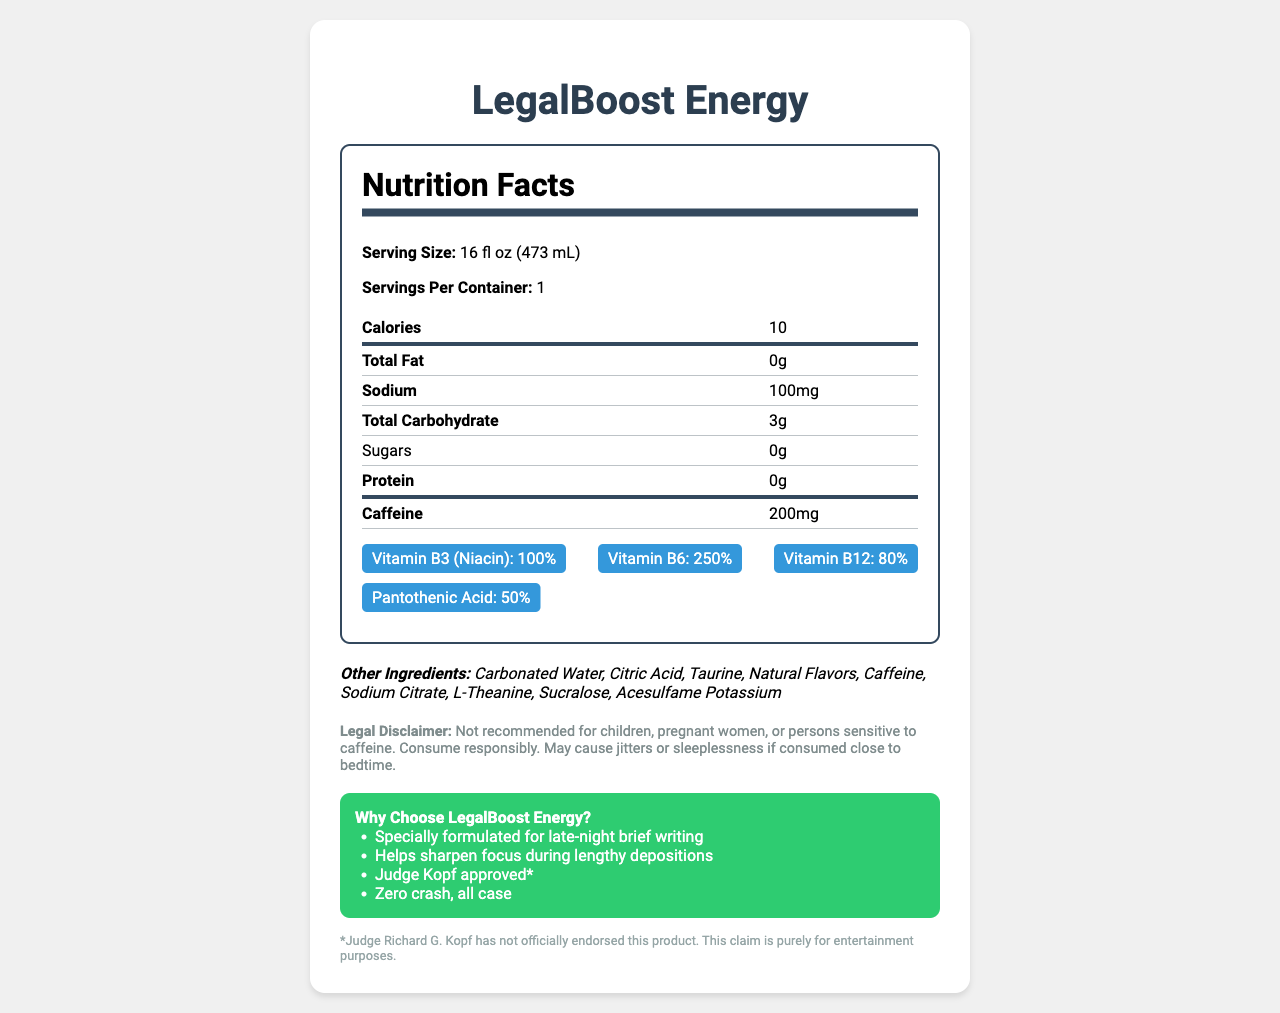What is the serving size of LegalBoost Energy? The document specifies that the serving size of LegalBoost Energy is 16 fl oz (473 mL).
Answer: 16 fl oz (473 mL) How many calories are in one serving of LegalBoost Energy? The document lists the calories per serving as 10.
Answer: 10 How much caffeine is there in one serving of LegalBoost Energy? The document notes that there are 200mg of caffeine per serving.
Answer: 200mg List the vitamins and minerals along with their percentages that are included in LegalBoost Energy. These values are provided in the vitamins and minerals section of the document.
Answer: Vitamin B3 (Niacin): 100%, Vitamin B6: 250%, Vitamin B12: 80%, Pantothenic Acid: 50% What is the total carbohydrate content in one serving of LegalBoost Energy? The document specifies that the total carbohydrate content is 3g.
Answer: 3g Which of the following marketing claims is made by LegalBoost Energy?
A. Contains natural sugars
B. Specially formulated for late-night brief writing
C. Certified organic The document includes the marketing claim "Specially formulated for late-night brief writing."
Answer: B What is the sodium content in one serving of LegalBoost Energy?
A. 50mg
B. 100mg
C. 200mg The document states that the sodium content is 100mg per serving.
Answer: B Is the product recommended for children? The legal disclaimer states that the product is "Not recommended for children."
Answer: No Summarize the main idea of the LegalBoost Energy nutrition label. The document details the nutritional content, ingredients, marketing claims, and legal disclaimer related to the LegalBoost Energy drink.
Answer: LegalBoost Energy is an energy drink marketed to lawyers with high caffeine content and various B-vitamins. It includes claims to enhance late-night work, and it provides nutritional information and a legal disclaimer on consumption. Who has officially endorsed LegalBoost Energy? The footnote states that Judge Richard G. Kopf has not officially endorsed the product, and this claim is for entertainment purposes.
Answer: Not enough information What are the "other ingredients" listed in LegalBoost Energy? These are listed under the "Other Ingredients" section in the document.
Answer: Carbonated Water, Citric Acid, Taurine, Natural Flavors, Caffeine, Sodium Citrate, L-Theanine, Sucralose, Acesulfame Potassium 